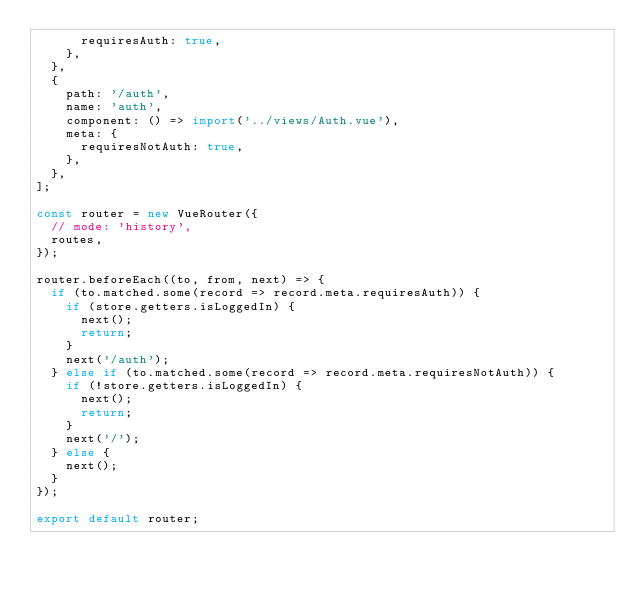<code> <loc_0><loc_0><loc_500><loc_500><_JavaScript_>			requiresAuth: true,
		},
	},
	{
		path: '/auth',
		name: 'auth',
		component: () => import('../views/Auth.vue'),
		meta: {
			requiresNotAuth: true,
		},
	},
];

const router = new VueRouter({
	// mode: 'history',
	routes,
});

router.beforeEach((to, from, next) => {
	if (to.matched.some(record => record.meta.requiresAuth)) {
		if (store.getters.isLoggedIn) {
			next();
			return;
		}
		next('/auth');
	} else if (to.matched.some(record => record.meta.requiresNotAuth)) {
		if (!store.getters.isLoggedIn) {
			next();
			return;
		}
		next('/');
	} else {
		next();
	}
});

export default router;
</code> 